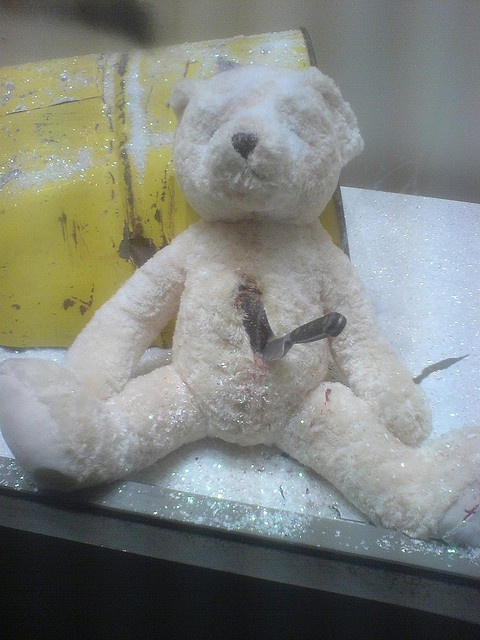Describe the objects in this image and their specific colors. I can see teddy bear in black, darkgray, gray, and lightgray tones and knife in black, gray, and darkgray tones in this image. 